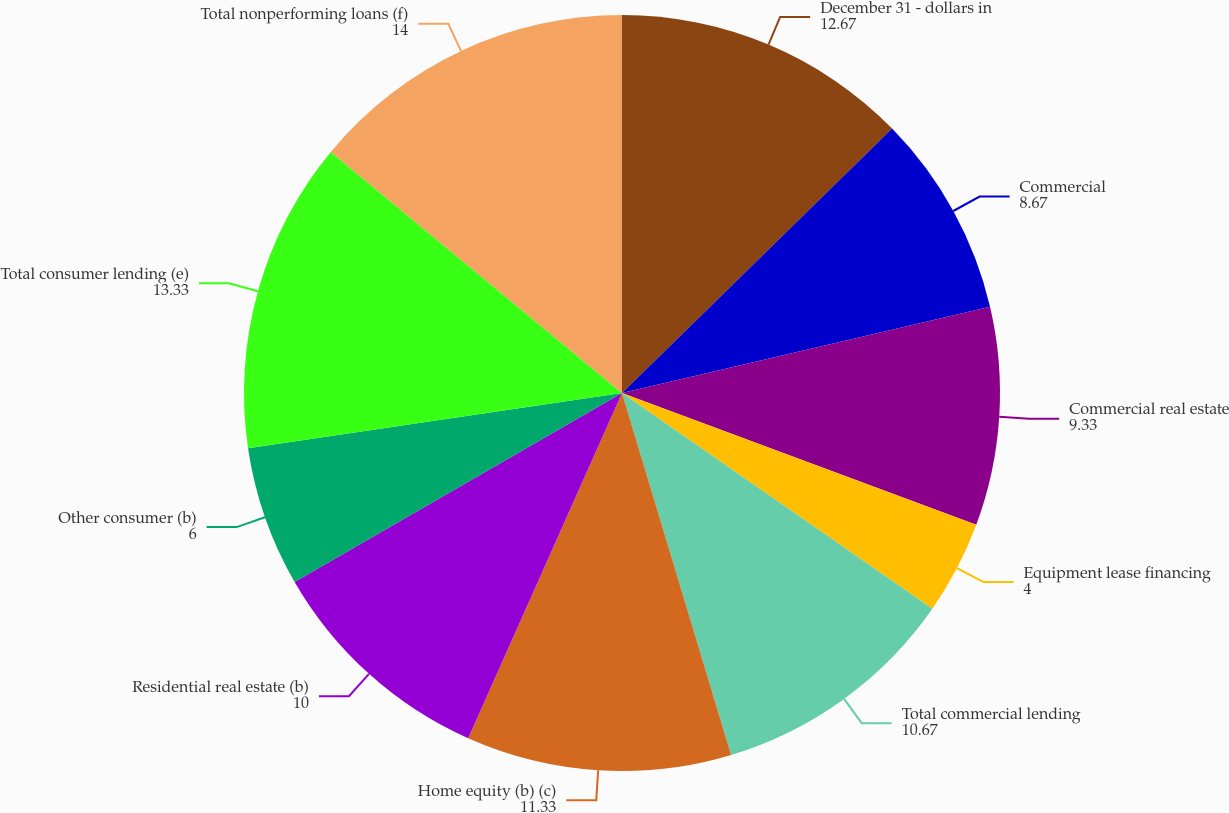Convert chart. <chart><loc_0><loc_0><loc_500><loc_500><pie_chart><fcel>December 31 - dollars in<fcel>Commercial<fcel>Commercial real estate<fcel>Equipment lease financing<fcel>Total commercial lending<fcel>Home equity (b) (c)<fcel>Residential real estate (b)<fcel>Other consumer (b)<fcel>Total consumer lending (e)<fcel>Total nonperforming loans (f)<nl><fcel>12.67%<fcel>8.67%<fcel>9.33%<fcel>4.0%<fcel>10.67%<fcel>11.33%<fcel>10.0%<fcel>6.0%<fcel>13.33%<fcel>14.0%<nl></chart> 